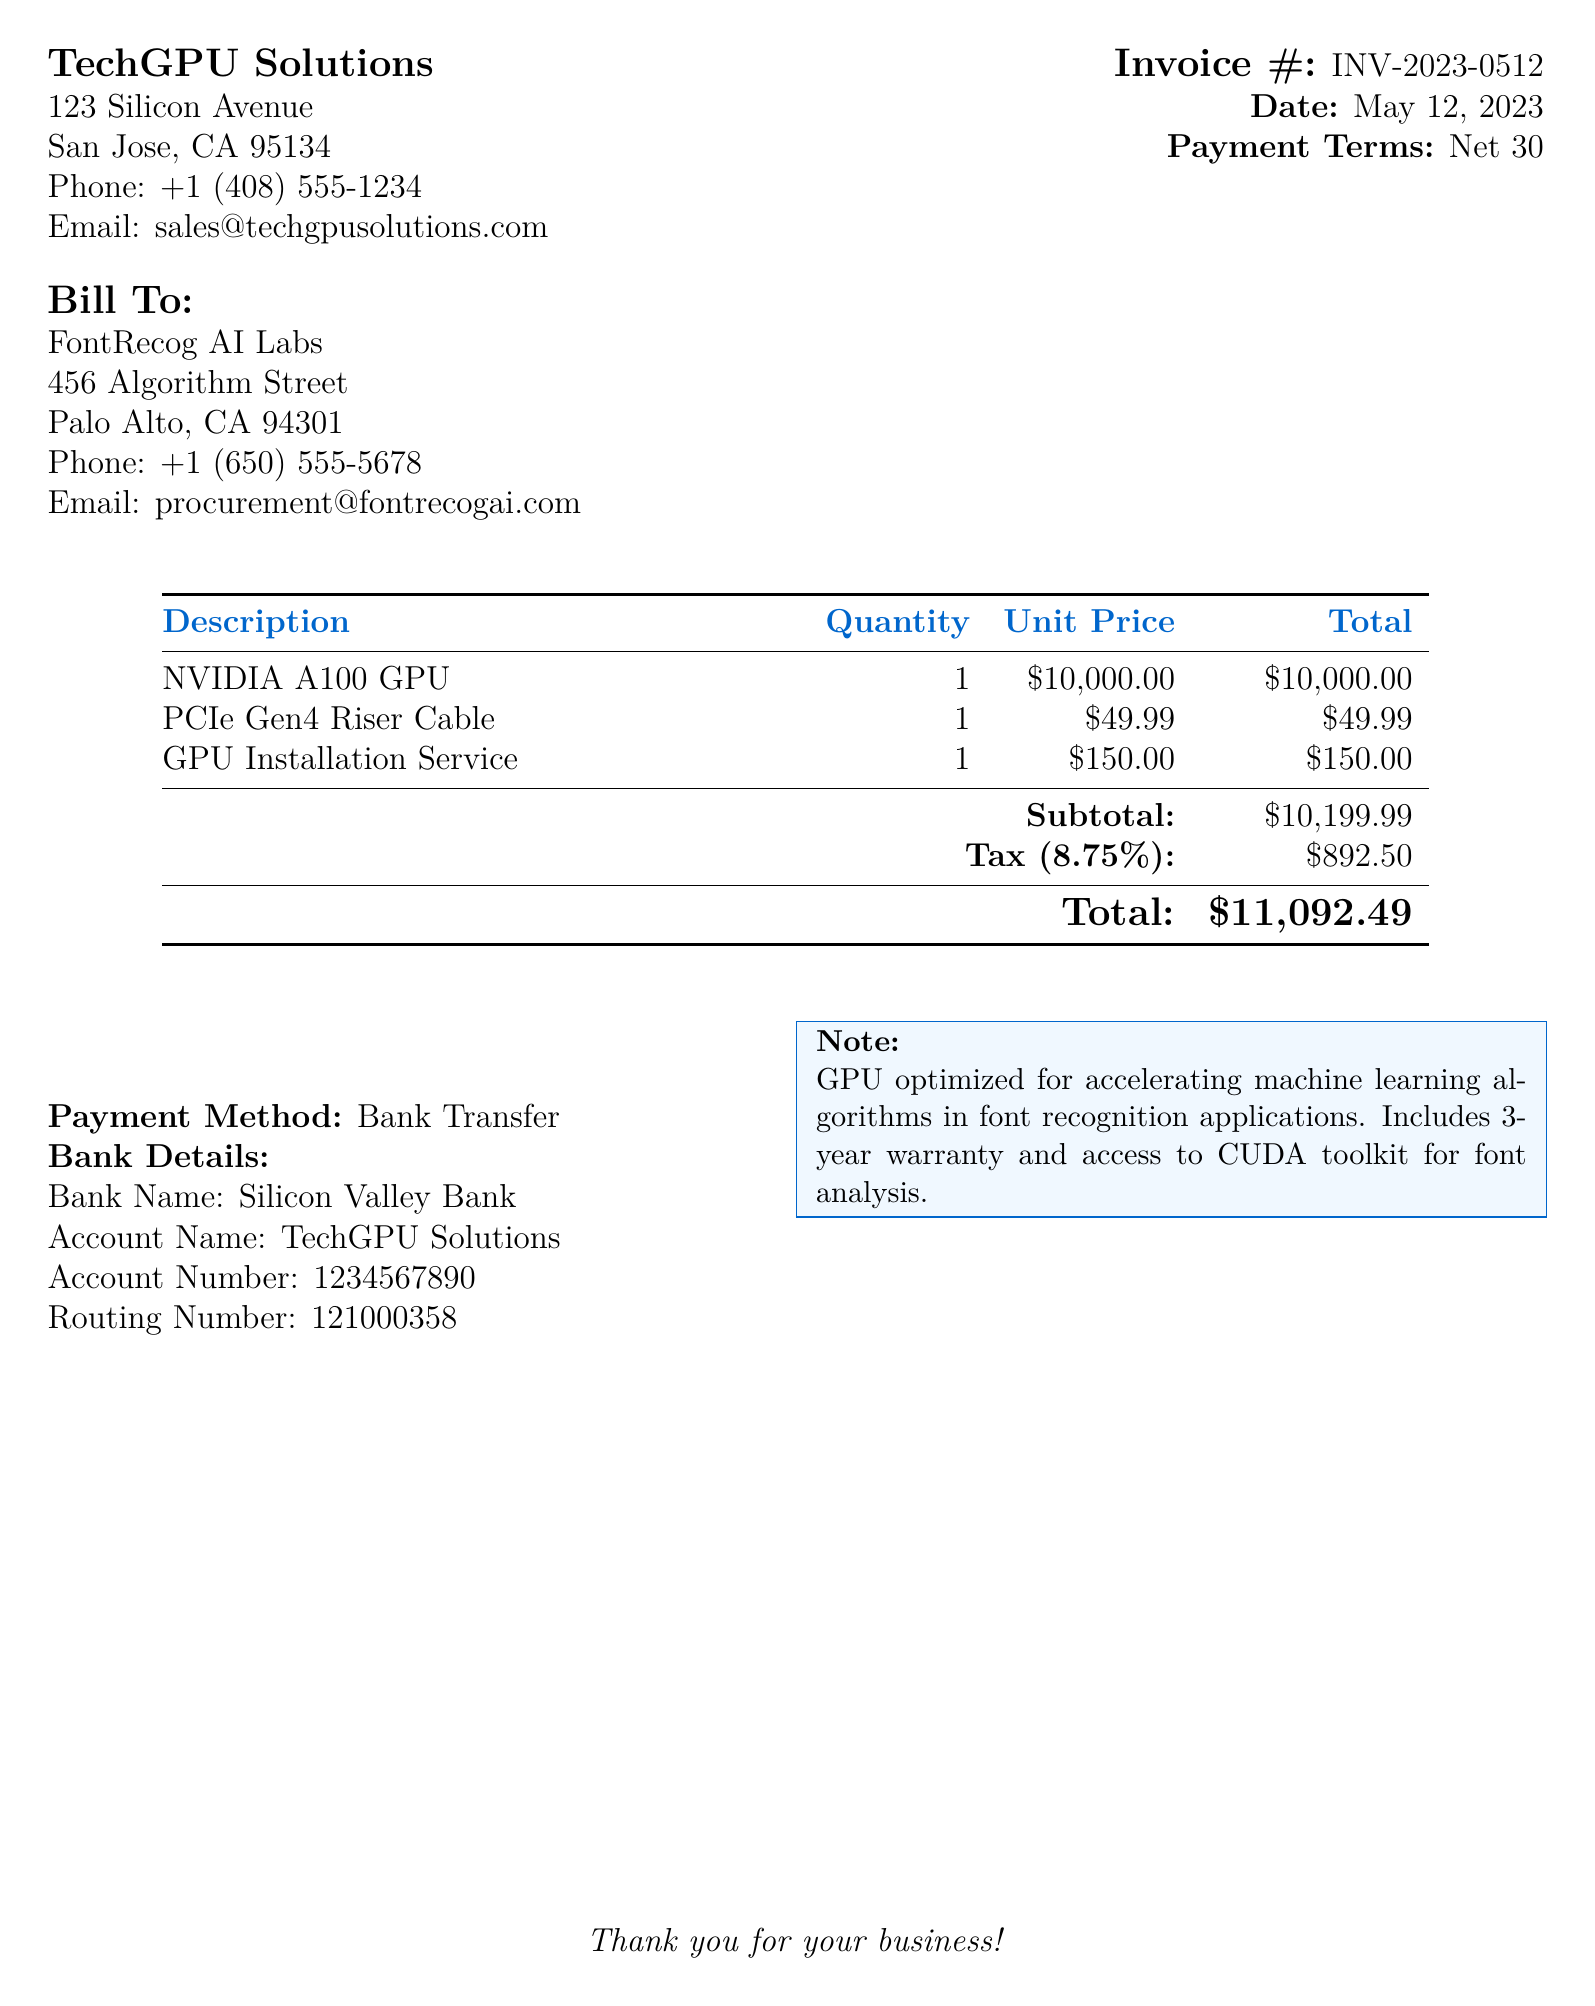What is the invoice number? The invoice number is listed near the date at the top of the document.
Answer: INV-2023-0512 What is the total amount due? The total amount due is calculated after adding the subtotal and tax.
Answer: $11,092.49 Who is the billing recipient? The billing recipient's name is provided at the start of the billing section.
Answer: FontRecog AI Labs What was the unit price of the NVIDIA A100 GPU? The unit price for the GPU is specified in the itemized list.
Answer: $10,000.00 What is the date of the invoice? The date is mentioned right under the invoice number on the document.
Answer: May 12, 2023 What percentage is the tax applied? The tax percentage can be found in the subtotal section of the bill.
Answer: 8.75% What service is included along with the GPU purchase? The document lists additional services along with the product in the itemized list.
Answer: GPU Installation Service What payment method is stated in the invoice? The payment method is usually mentioned towards the end of the invoice.
Answer: Bank Transfer What is the subtotal before tax? The subtotal is calculated before the tax is added, located in the itemized list.
Answer: $10,199.99 What is stated in the note section? The note section summarizes additional pertinent details about the product purchased.
Answer: GPU optimized for accelerating machine learning algorithms in font recognition applications. Includes 3-year warranty and access to CUDA toolkit for font analysis 